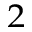Convert formula to latex. <formula><loc_0><loc_0><loc_500><loc_500>^ { 2 }</formula> 